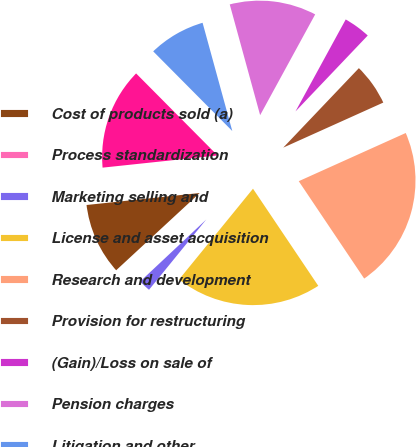Convert chart. <chart><loc_0><loc_0><loc_500><loc_500><pie_chart><fcel>Cost of products sold (a)<fcel>Process standardization<fcel>Marketing selling and<fcel>License and asset acquisition<fcel>Research and development<fcel>Provision for restructuring<fcel>(Gain)/Loss on sale of<fcel>Pension charges<fcel>Litigation and other<fcel>Other (income)/expense<nl><fcel>10.2%<fcel>0.11%<fcel>2.13%<fcel>20.3%<fcel>22.32%<fcel>6.16%<fcel>4.15%<fcel>12.22%<fcel>8.18%<fcel>14.24%<nl></chart> 